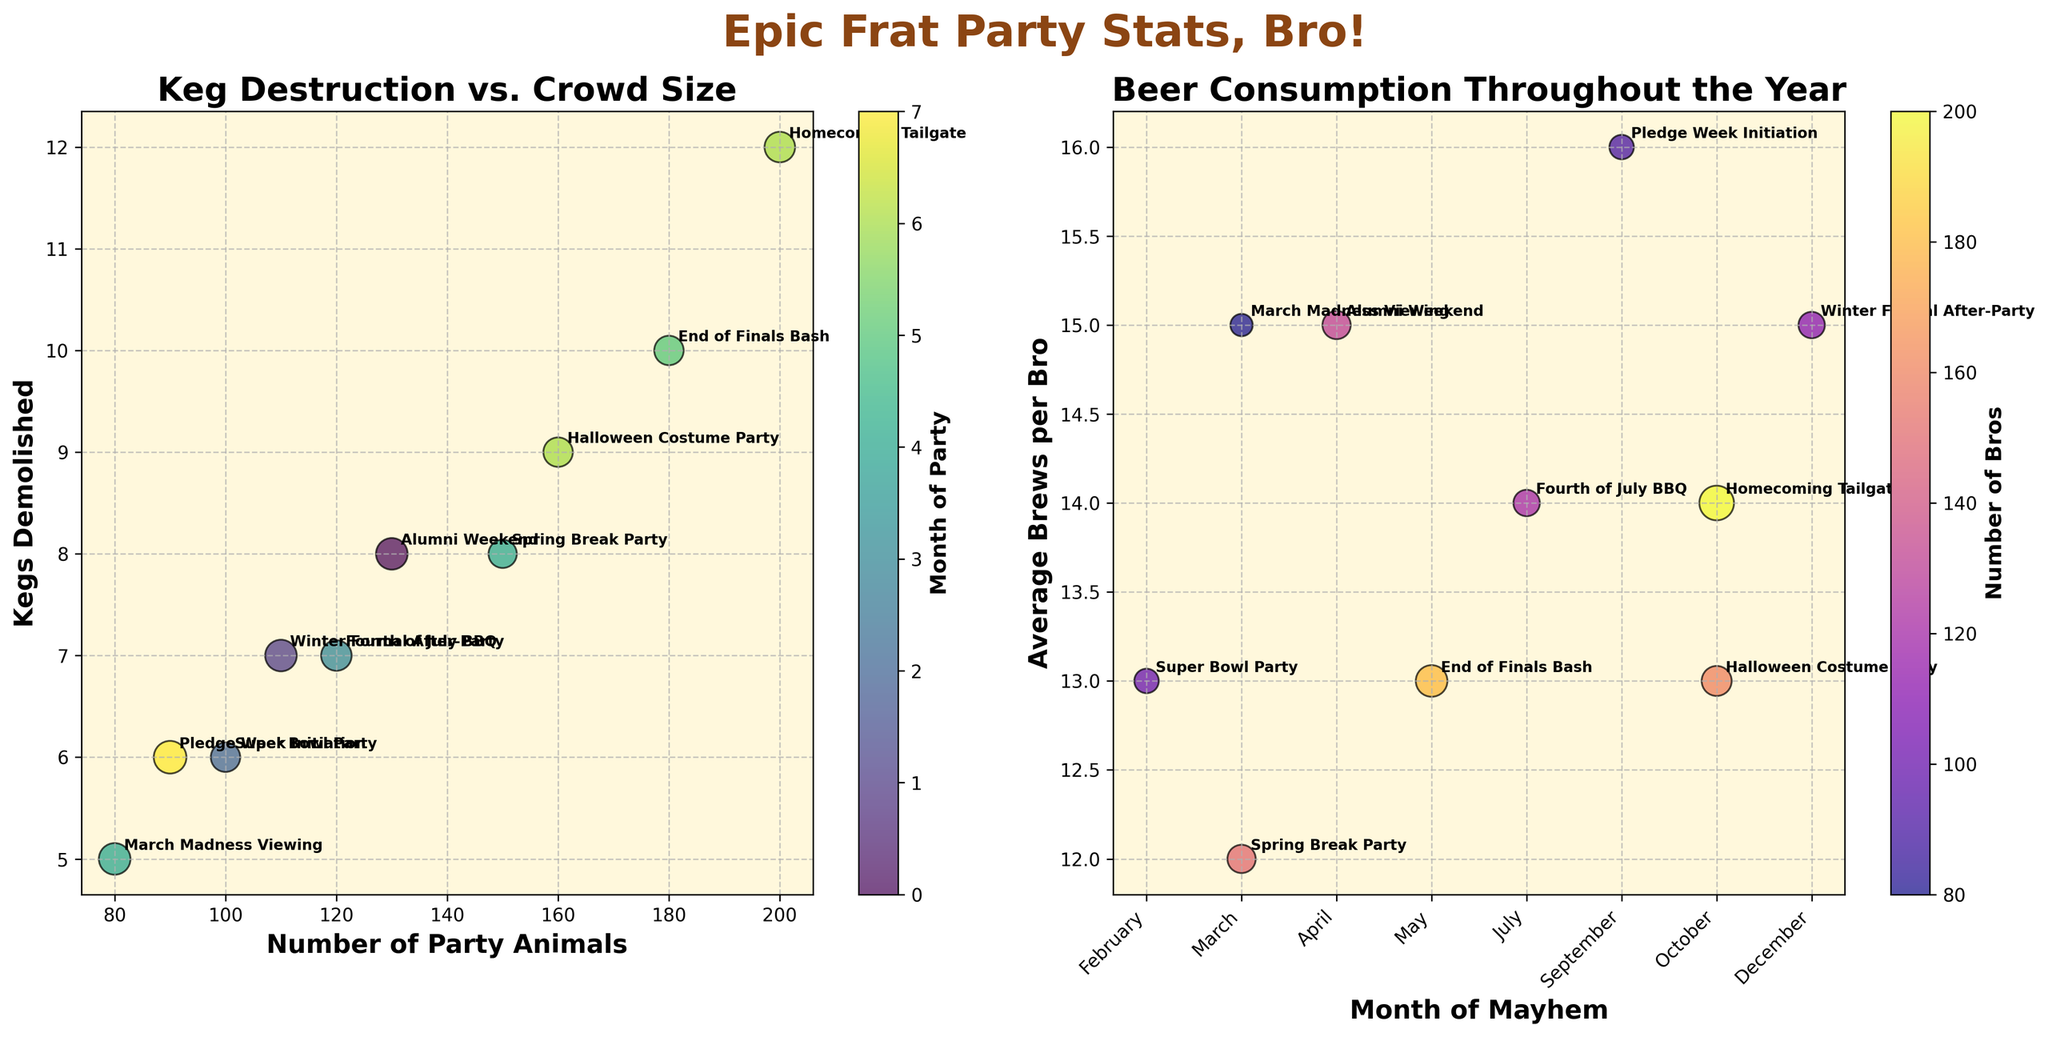What's the title of the figure? The title is displayed at the top of the whole figure.
Answer: Epic Frat Party Stats, Bro! What are the axes labels of the first subplot? The first subplot has axes labels on both the X-axis and Y-axis. The X-axis is labeled 'Number of Party Animals,' and the Y-axis is labeled 'Kegs Demolished.'
Answer: Number of Party Animals, Kegs Demolished Which event had the highest number of attendees? We need to look at the first subplot and find the largest number on the X-axis labeled 'Number of Party Animals.' The event annotated at this point is the 'Homecoming Tailgate.'
Answer: Homecoming Tailgate How many kegs were consumed at the End of Finals Bash? Find the 'End of Finals Bash' annotation on the first subplot. This point's Y-coordinate indicates the number of kegs consumed, which is 10.
Answer: 10 During which month was the event with the highest average beers per person? The second subplot shows the average beers per person versus the month. Locate the highest point on the Y-axis and trace back to the corresponding month. The highest point is 'Pledge Week Initiation' in September.
Answer: September Compare the kegs consumed during the Spring Break Party and Halloween Costume Party. Which event consumed more kegs? Identify the points for 'Spring Break Party' and 'Halloween Costume Party' on the first subplot and compare their positions on the Y-axis. 'Halloween Costume Party' consumed 9 kegs, while 'Spring Break Party' consumed 8 kegs.
Answer: Halloween Costume Party What is the color map used in the first subplot? The first subplot uses a color gradient to represent different months, and this is indicated by the color scale next to the subplot, which is titled 'Month of Party.' The color map is 'viridis.'
Answer: viridis How does the size of bubbles change for different values of average beers per person in the first subplot? In the first subplot, larger bubbles represent higher average beers per person since bubble sizes are proportional to this value.
Answer: Larger values of average beers per person have bigger bubbles What's the average number of kegs consumed across all events? Sum the number of kegs for each event (8 + 12 + 5 + 6 + 10 + 7 + 9 + 6 + 8 + 7) and divide by the number of events (10). The sum is 78, and the average is 78/10 = 7.8.
Answer: 7.8 In which event did the attendees consume the lowest number of beers per person on average? Check the second subplot and find the lowest point on the Y-axis. The event at this position is 'Spring Break Party' with 12 beers per person.
Answer: Spring Break Party 